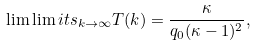Convert formula to latex. <formula><loc_0><loc_0><loc_500><loc_500>\lim \lim i t s _ { k \to \infty } T ( k ) = \frac { \kappa } { q _ { 0 } ( \kappa - 1 ) ^ { 2 } } ,</formula> 